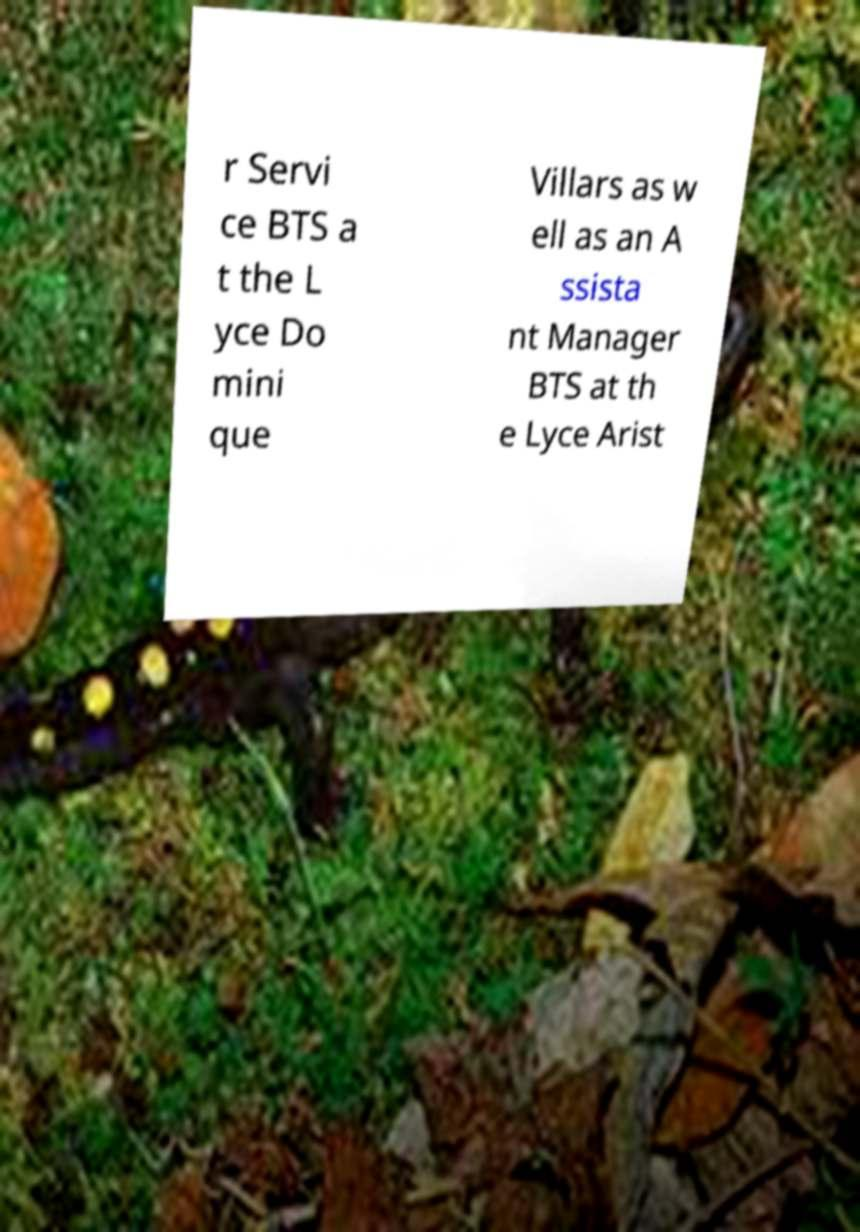Please identify and transcribe the text found in this image. r Servi ce BTS a t the L yce Do mini que Villars as w ell as an A ssista nt Manager BTS at th e Lyce Arist 